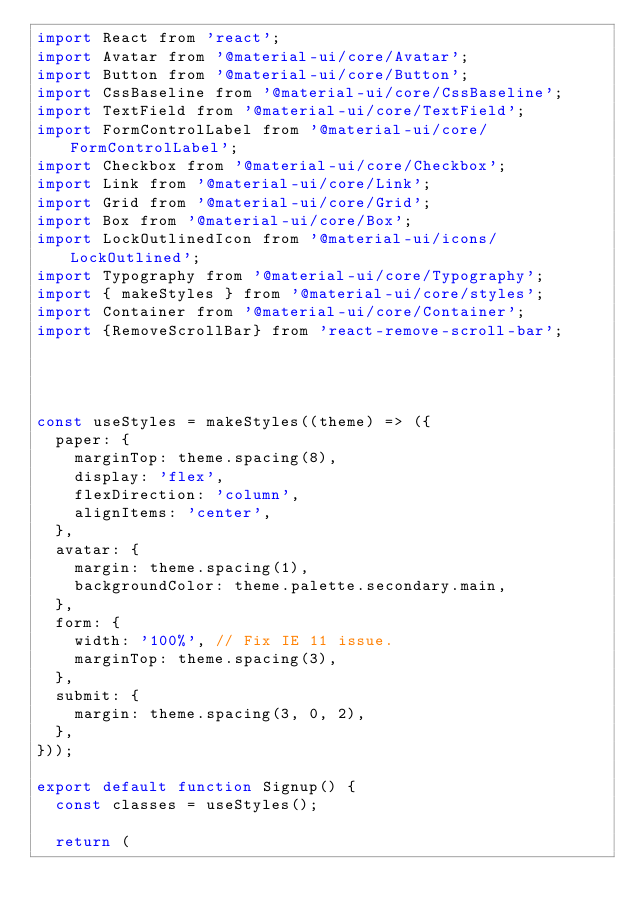Convert code to text. <code><loc_0><loc_0><loc_500><loc_500><_JavaScript_>import React from 'react';
import Avatar from '@material-ui/core/Avatar';
import Button from '@material-ui/core/Button';
import CssBaseline from '@material-ui/core/CssBaseline';
import TextField from '@material-ui/core/TextField';
import FormControlLabel from '@material-ui/core/FormControlLabel';
import Checkbox from '@material-ui/core/Checkbox';
import Link from '@material-ui/core/Link';
import Grid from '@material-ui/core/Grid';
import Box from '@material-ui/core/Box';
import LockOutlinedIcon from '@material-ui/icons/LockOutlined';
import Typography from '@material-ui/core/Typography';
import { makeStyles } from '@material-ui/core/styles';
import Container from '@material-ui/core/Container';
import {RemoveScrollBar} from 'react-remove-scroll-bar';




const useStyles = makeStyles((theme) => ({
  paper: {
    marginTop: theme.spacing(8),
    display: 'flex',
    flexDirection: 'column',
    alignItems: 'center',
  },
  avatar: {
    margin: theme.spacing(1),
    backgroundColor: theme.palette.secondary.main,
  },
  form: {
    width: '100%', // Fix IE 11 issue.
    marginTop: theme.spacing(3),
  },
  submit: {
    margin: theme.spacing(3, 0, 2),
  },
}));

export default function Signup() {
  const classes = useStyles();

  return (</code> 